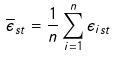Convert formula to latex. <formula><loc_0><loc_0><loc_500><loc_500>\overline { \epsilon } _ { s t } = \frac { 1 } { n } \sum _ { i = 1 } ^ { n } \epsilon _ { i s t }</formula> 